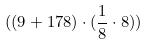Convert formula to latex. <formula><loc_0><loc_0><loc_500><loc_500>( ( 9 + 1 7 8 ) \cdot ( \frac { 1 } { 8 } \cdot 8 ) )</formula> 